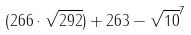Convert formula to latex. <formula><loc_0><loc_0><loc_500><loc_500>( 2 6 6 \cdot \sqrt { 2 9 2 } ) + 2 6 3 - \sqrt { 1 0 } ^ { 7 }</formula> 